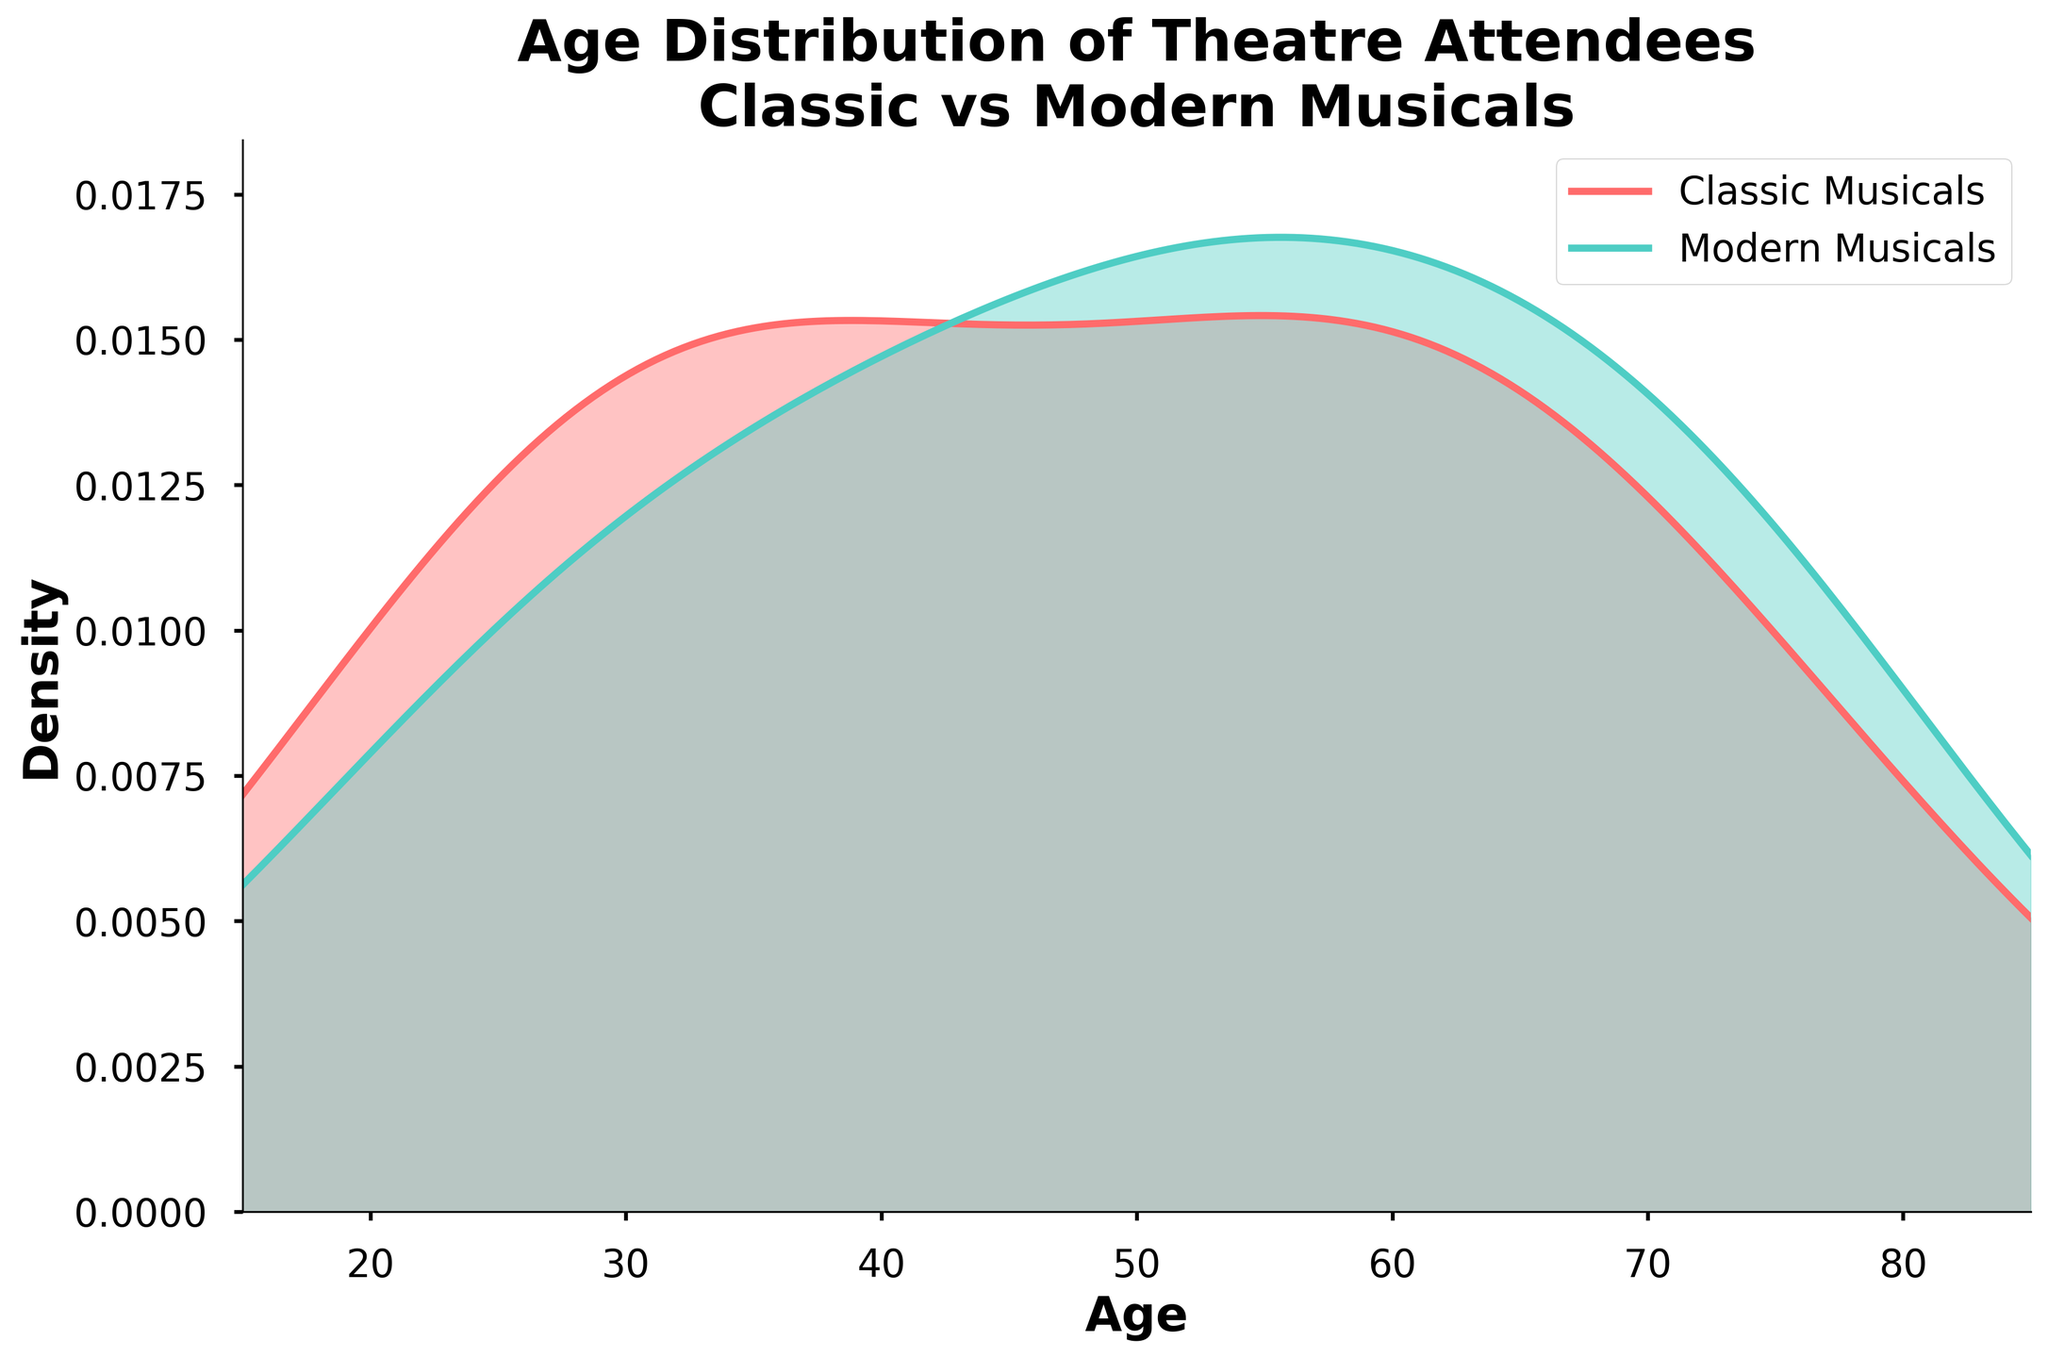What is the figure's title? The title is displayed at the top of the figure, and it usually provides a summary of the plot's information.
Answer: Age Distribution of Theatre Attendees: Classic vs Modern Musicals What ages have the highest density for classic musicals? By examining the peak point of the classic musicals' density curve (typically denoted in a distinct color), you can determine the age group with the highest density.
Answer: Around 60-65 years How do the age distributions of attendees for classic and modern musicals compare? To compare the distributions, look at the overall shape and peaks of the density lines for each genre. The classic musicals' density peaks at an older age group, while modern musicals' density peaks at a younger age group.
Answer: Classic peaks at an older age, modern peaks at a younger age What is the general shape of the density plot for modern musicals? Observing the density curve for modern musicals, which is typically filled in a specific color, you can describe its general shape and trends.
Answer: Moderately skewed towards younger ages At what approximate age do the density plots for classic and modern musicals intersect? The intersection point is found where the two density curves cross each other on the plot, indicating similar densities for both genres.
Answer: Around 50 years Compare the maximum density values for both classic and modern musicals. Which one is higher? By looking at the highest points on both density curves, you can compare which peak is higher. The height indicates the maximum density values.
Answer: Classic musical What is the range of ages considered in the density plot? The range can be determined by checking the x-axis limits or the minimum and maximum ages plotted.
Answer: 15 to 85 years What can you infer about the variability of attendee ages for modern musicals compared to classic musicals? To infer variability, look at the spread and width of the density curves for both genres. Wider curves suggest more variability in the ages of the attendees.
Answer: Modern musicals show more variability Which age group is least likely to attend either classic or modern musicals based on the plot? Identify the age range on the x-axis where both density curves are at their lowest points, indicating the least likelihood of attendance.
Answer: Ages 15-20 years Does the plot suggest that classic musicals draw an older audience compared to modern musicals? By comparing the general age distributions and the peaks of each density line, you can see which genre has higher density values at older ages.
Answer: Yes 